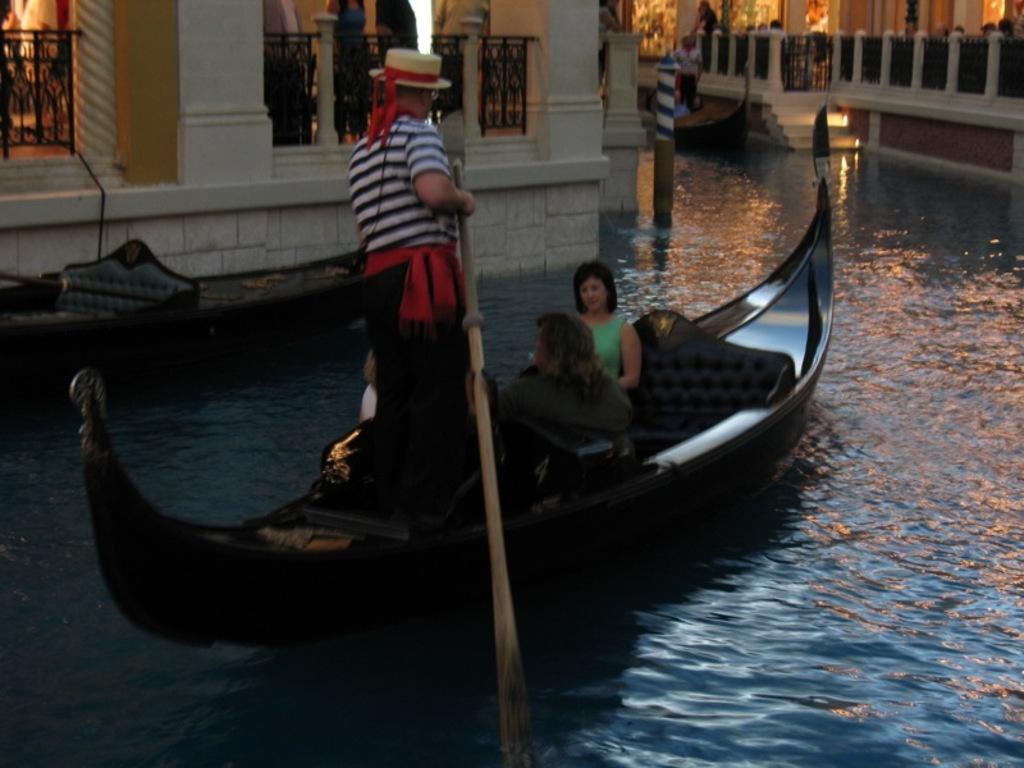Describe this image in one or two sentences. In this image we can see some people sitting in a boat which is on the water. We can also see a man in a boat holding a row. On the backside we can see a boat, a building, a pole and some trees. 